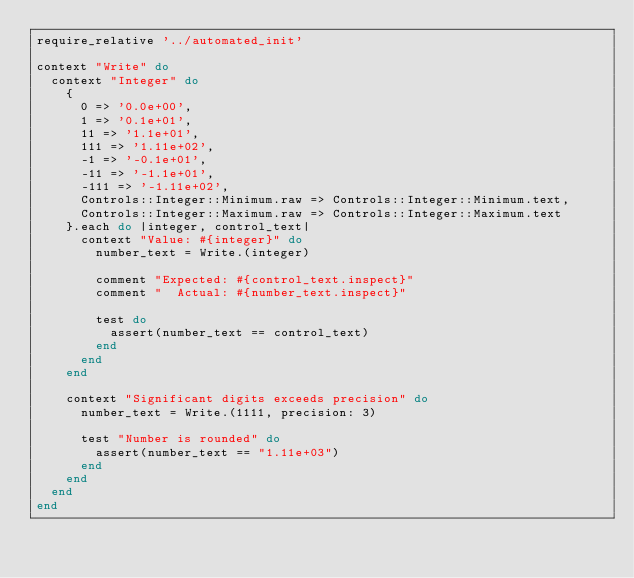<code> <loc_0><loc_0><loc_500><loc_500><_Ruby_>require_relative '../automated_init'

context "Write" do
  context "Integer" do
    {
      0 => '0.0e+00',
      1 => '0.1e+01',
      11 => '1.1e+01',
      111 => '1.11e+02',
      -1 => '-0.1e+01',
      -11 => '-1.1e+01',
      -111 => '-1.11e+02',
      Controls::Integer::Minimum.raw => Controls::Integer::Minimum.text,
      Controls::Integer::Maximum.raw => Controls::Integer::Maximum.text
    }.each do |integer, control_text|
      context "Value: #{integer}" do
        number_text = Write.(integer)

        comment "Expected: #{control_text.inspect}"
        comment "  Actual: #{number_text.inspect}"

        test do
          assert(number_text == control_text)
        end
      end
    end

    context "Significant digits exceeds precision" do
      number_text = Write.(1111, precision: 3)

      test "Number is rounded" do
        assert(number_text == "1.11e+03")
      end
    end
  end
end
</code> 